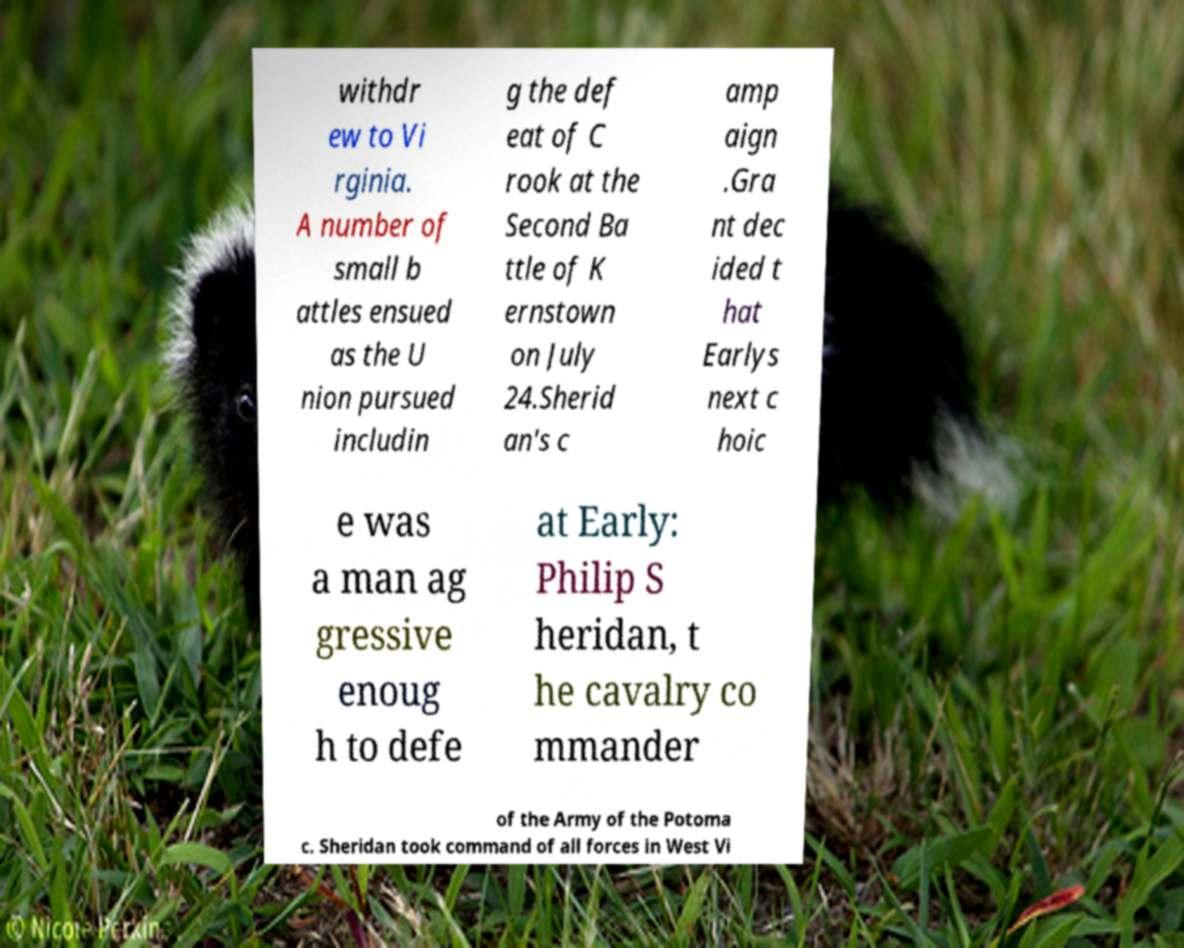I need the written content from this picture converted into text. Can you do that? withdr ew to Vi rginia. A number of small b attles ensued as the U nion pursued includin g the def eat of C rook at the Second Ba ttle of K ernstown on July 24.Sherid an's c amp aign .Gra nt dec ided t hat Earlys next c hoic e was a man ag gressive enoug h to defe at Early: Philip S heridan, t he cavalry co mmander of the Army of the Potoma c. Sheridan took command of all forces in West Vi 